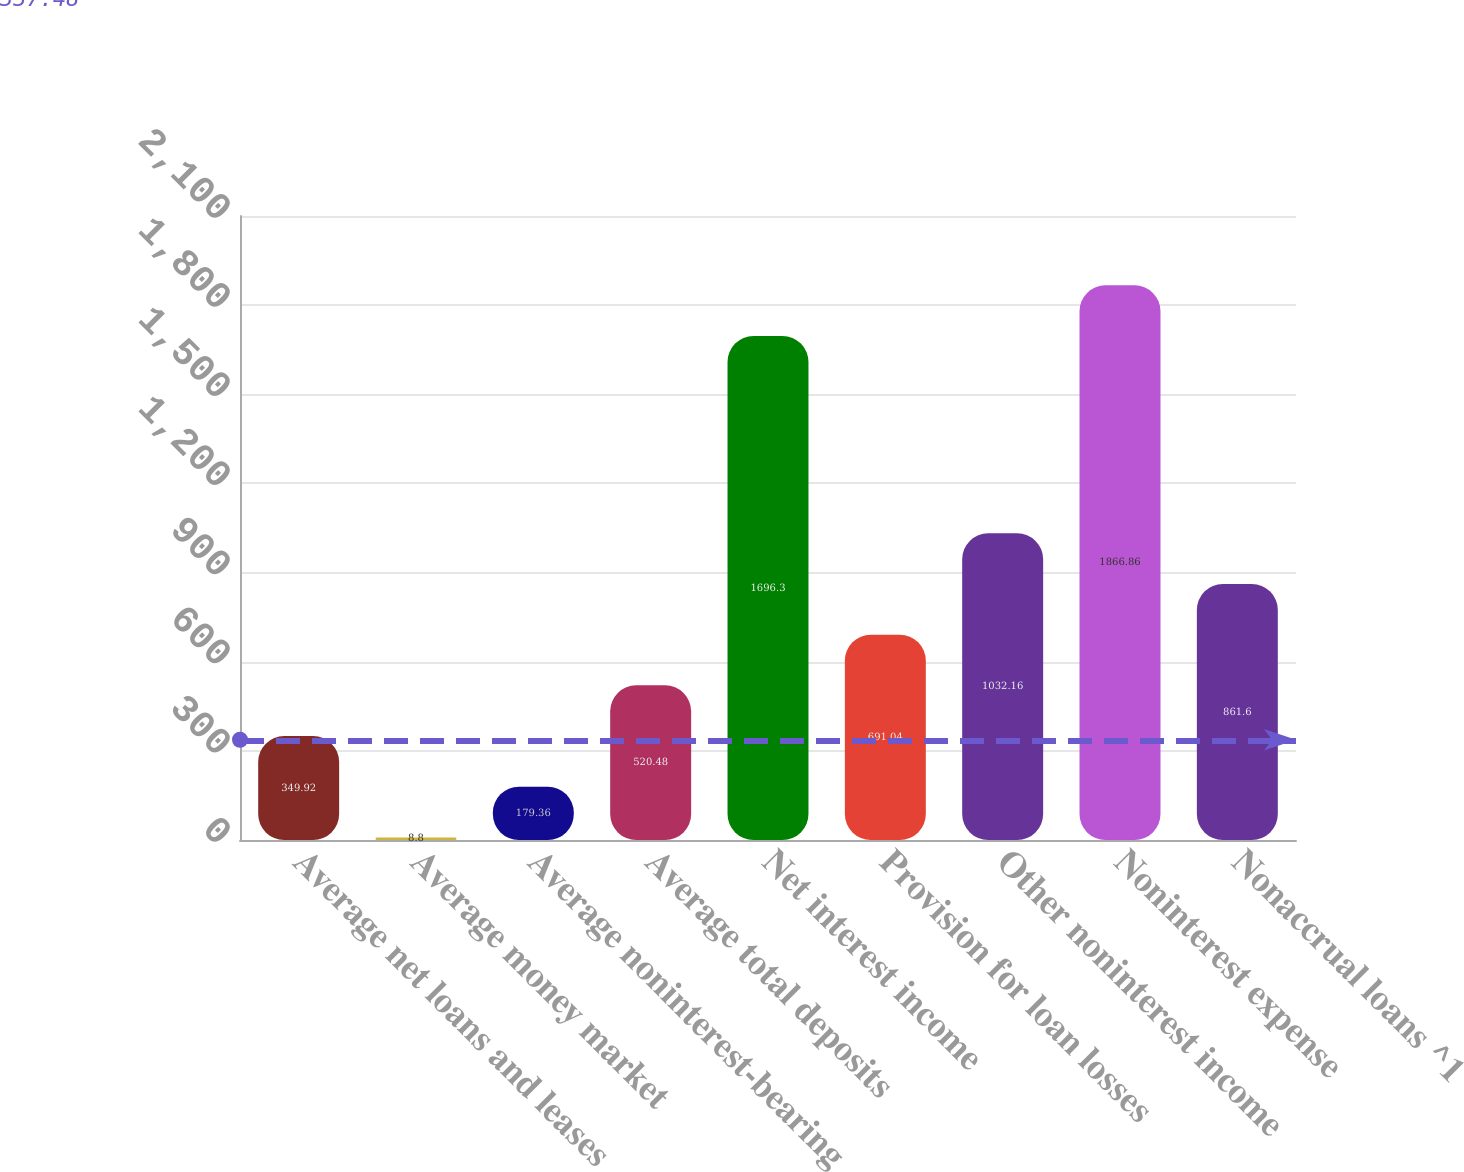Convert chart. <chart><loc_0><loc_0><loc_500><loc_500><bar_chart><fcel>Average net loans and leases<fcel>Average money market<fcel>Average noninterest-bearing<fcel>Average total deposits<fcel>Net interest income<fcel>Provision for loan losses<fcel>Other noninterest income<fcel>Noninterest expense<fcel>Nonaccrual loans ^1<nl><fcel>349.92<fcel>8.8<fcel>179.36<fcel>520.48<fcel>1696.3<fcel>691.04<fcel>1032.16<fcel>1866.86<fcel>861.6<nl></chart> 